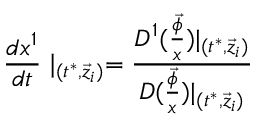Convert formula to latex. <formula><loc_0><loc_0><loc_500><loc_500>\frac { d x ^ { 1 } } { d t } | _ { ( t ^ { * } , \vec { z } _ { i } ) } = \frac { D ^ { 1 } ( \frac { \vec { \phi } } x ) | _ { ( t ^ { * } , \vec { z } _ { i } ) } } { D ( \frac { \vec { \phi } } x ) | _ { ( t ^ { * } , \vec { z } _ { i } ) } }</formula> 